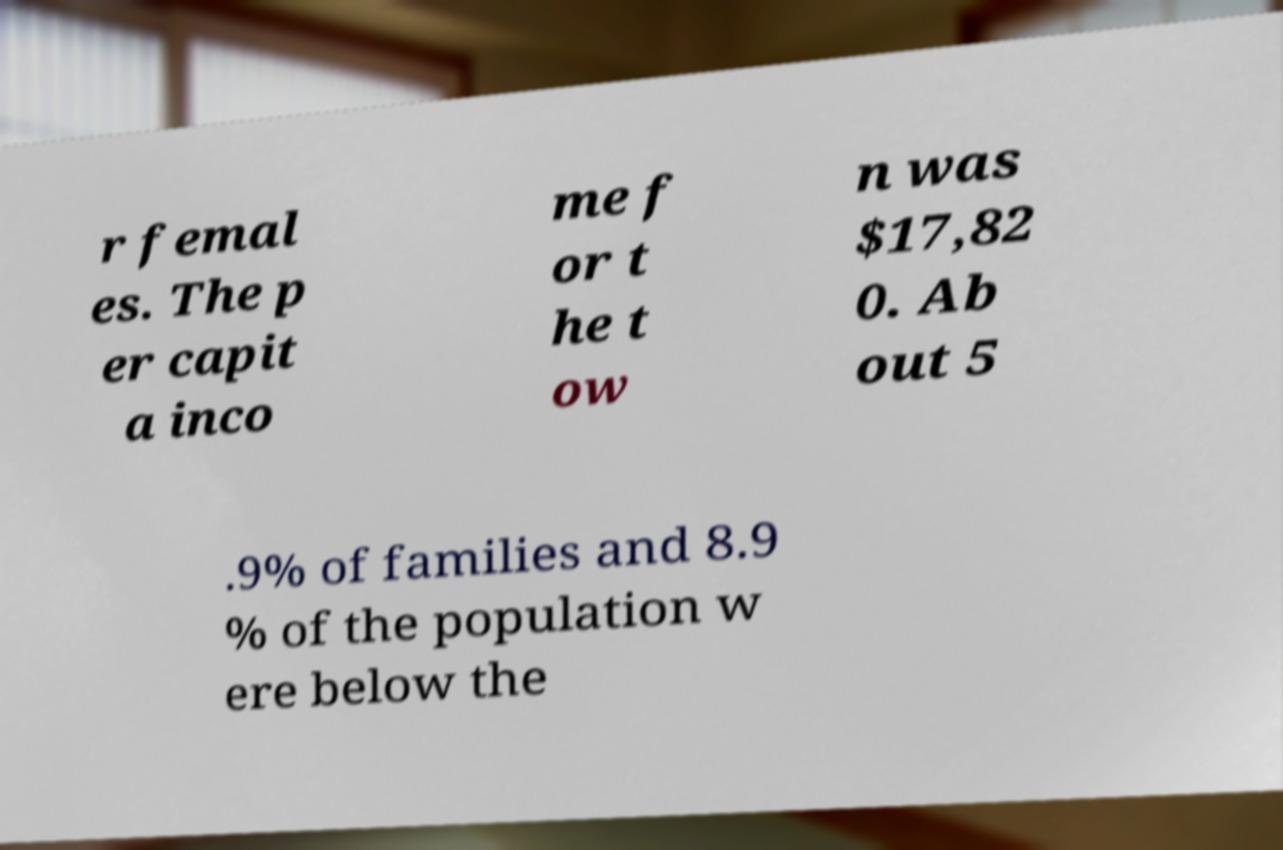There's text embedded in this image that I need extracted. Can you transcribe it verbatim? r femal es. The p er capit a inco me f or t he t ow n was $17,82 0. Ab out 5 .9% of families and 8.9 % of the population w ere below the 